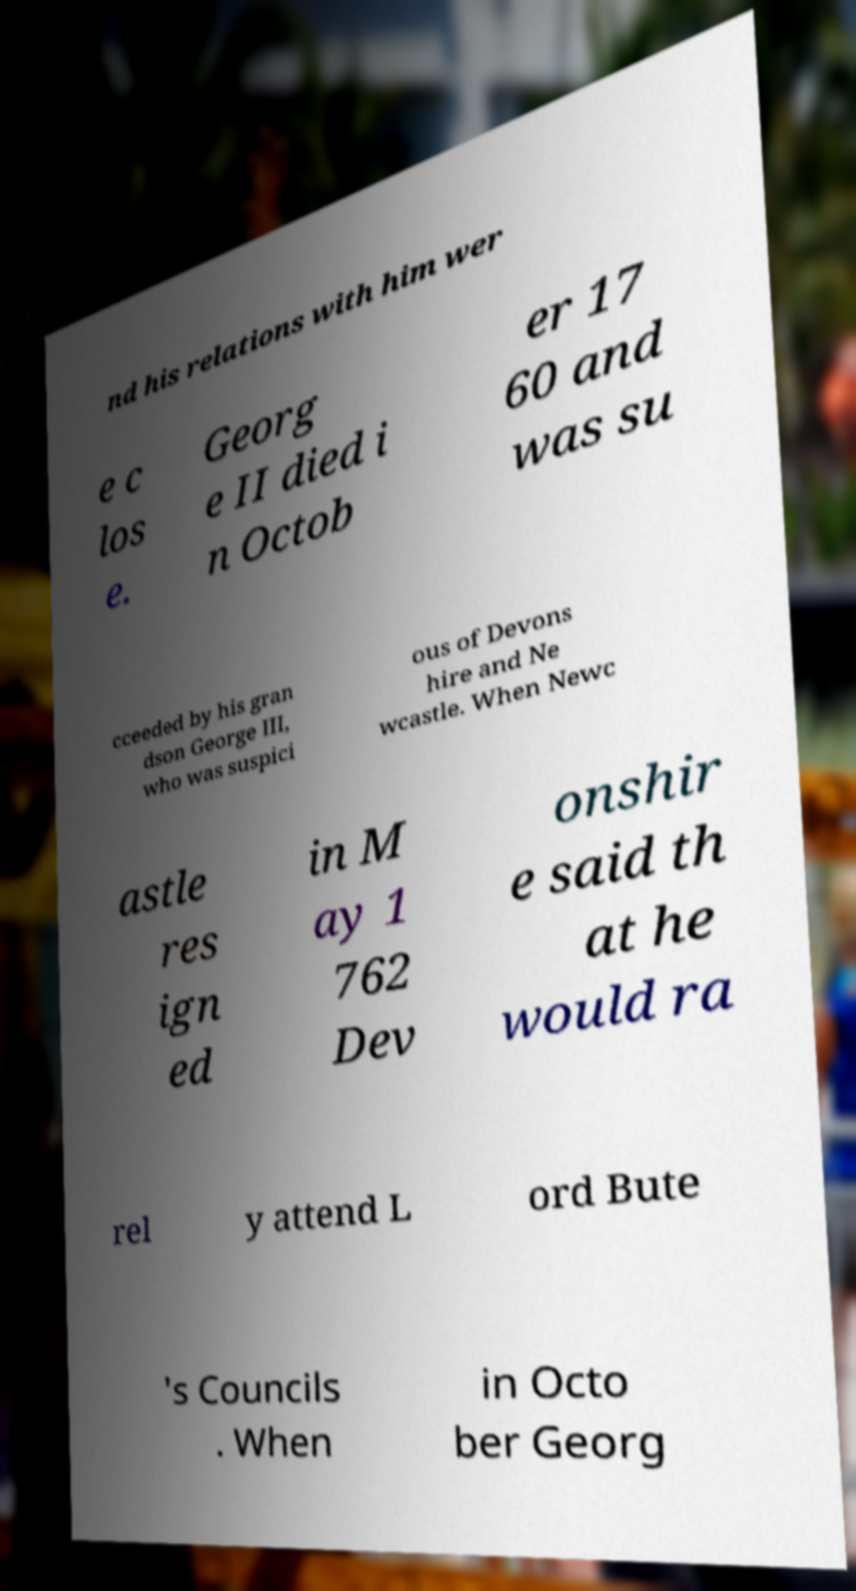Can you read and provide the text displayed in the image?This photo seems to have some interesting text. Can you extract and type it out for me? nd his relations with him wer e c los e. Georg e II died i n Octob er 17 60 and was su cceeded by his gran dson George III, who was suspici ous of Devons hire and Ne wcastle. When Newc astle res ign ed in M ay 1 762 Dev onshir e said th at he would ra rel y attend L ord Bute 's Councils . When in Octo ber Georg 